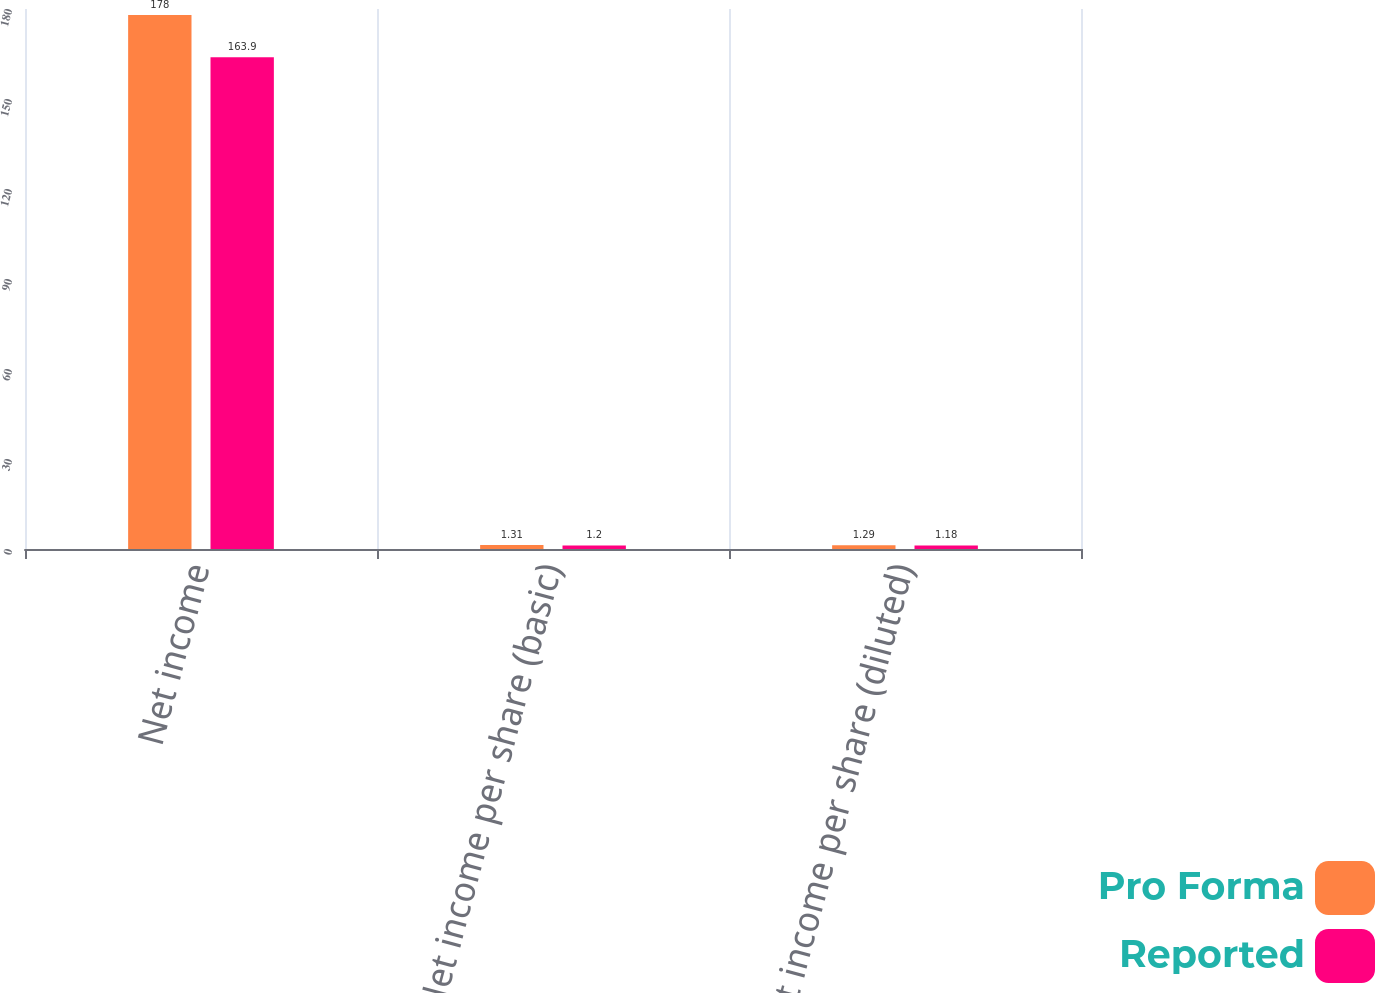Convert chart to OTSL. <chart><loc_0><loc_0><loc_500><loc_500><stacked_bar_chart><ecel><fcel>Net income<fcel>Net income per share (basic)<fcel>Net income per share (diluted)<nl><fcel>Pro Forma<fcel>178<fcel>1.31<fcel>1.29<nl><fcel>Reported<fcel>163.9<fcel>1.2<fcel>1.18<nl></chart> 